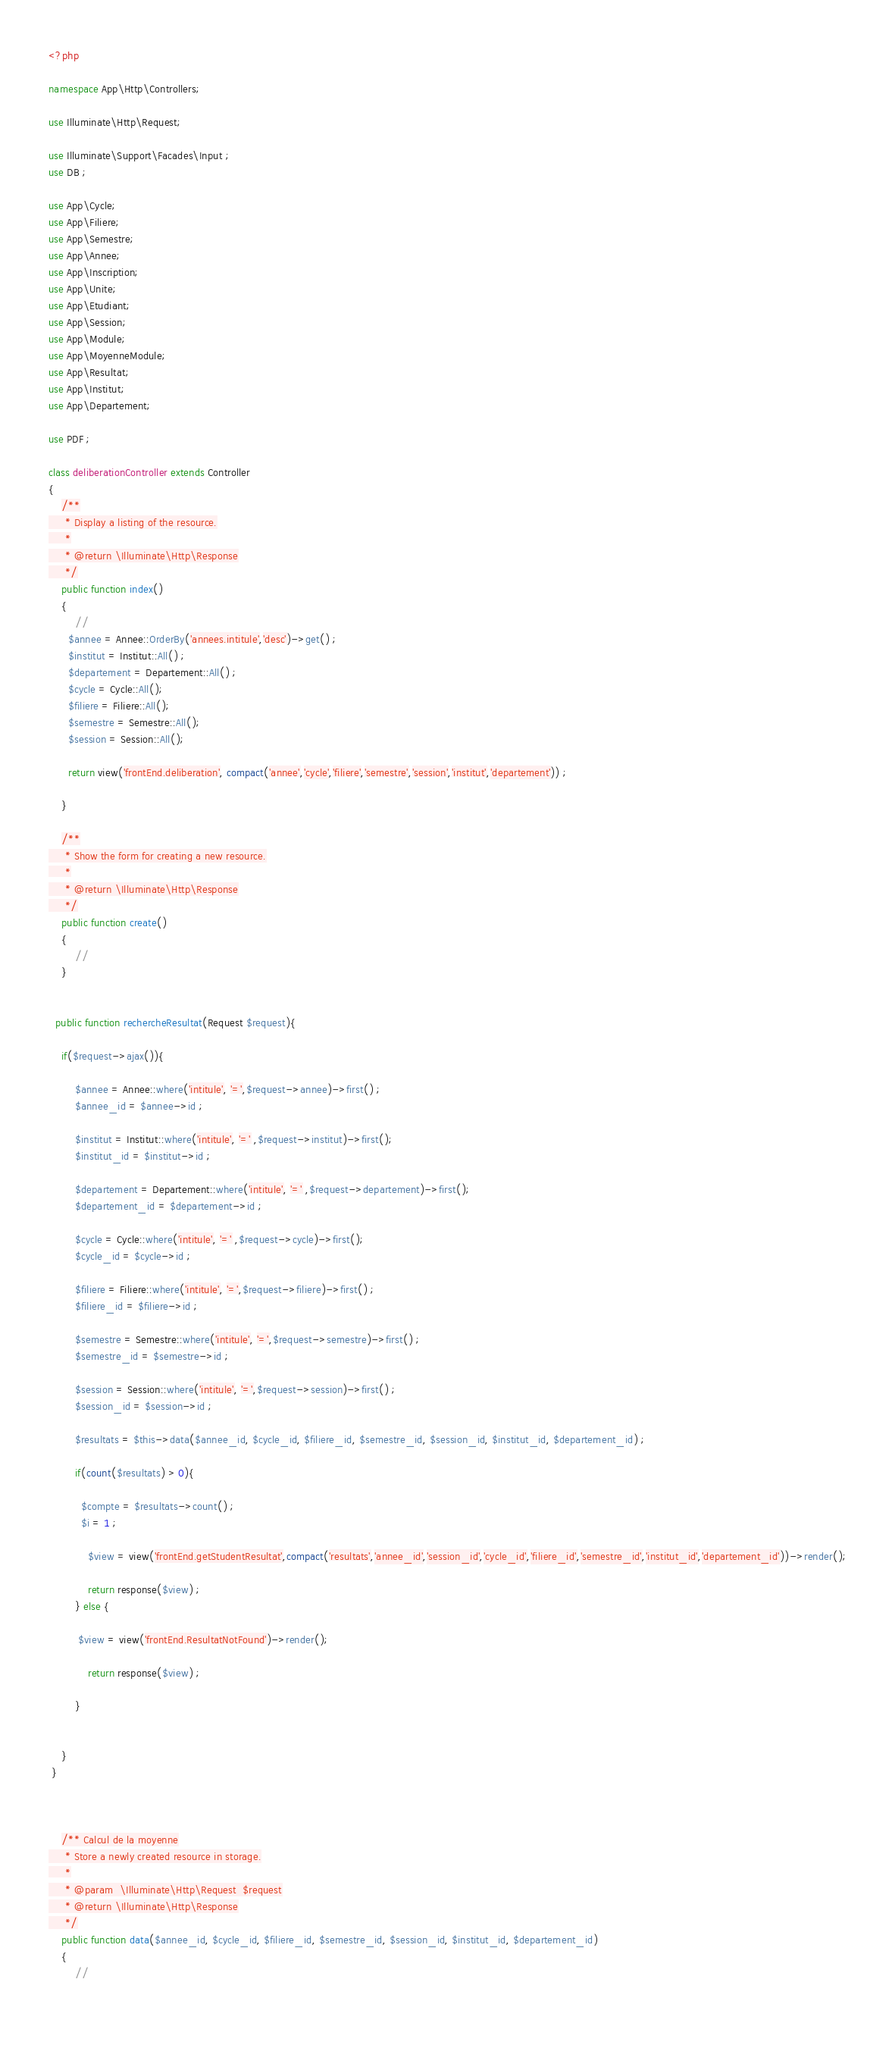<code> <loc_0><loc_0><loc_500><loc_500><_PHP_><?php

namespace App\Http\Controllers;

use Illuminate\Http\Request;

use Illuminate\Support\Facades\Input ;
use DB ;

use App\Cycle;
use App\Filiere;
use App\Semestre;
use App\Annee;
use App\Inscription;
use App\Unite;
use App\Etudiant;
use App\Session;
use App\Module;
use App\MoyenneModule;
use App\Resultat;
use App\Institut;
use App\Departement;

use PDF ;

class deliberationController extends Controller
{
    /**
     * Display a listing of the resource.
     *
     * @return \Illuminate\Http\Response
     */
    public function index()
    {
        //
      $annee = Annee::OrderBy('annees.intitule','desc')->get() ;
      $institut = Institut::All() ;
      $departement = Departement::All() ;
      $cycle = Cycle::All();
      $filiere = Filiere::All();
      $semestre = Semestre::All();
      $session = Session::All();

      return view('frontEnd.deliberation', compact('annee','cycle','filiere','semestre','session','institut','departement')) ;

    }

    /**
     * Show the form for creating a new resource.
     *
     * @return \Illuminate\Http\Response
     */
    public function create()
    {
        //
    }


  public function rechercheResultat(Request $request){

    if($request->ajax()){

        $annee = Annee::where('intitule', '=',$request->annee)->first() ;
        $annee_id = $annee->id ;

        $institut = Institut::where('intitule', '=' ,$request->institut)->first();
        $institut_id = $institut->id ;

        $departement = Departement::where('intitule', '=' ,$request->departement)->first();
        $departement_id = $departement->id ;

        $cycle = Cycle::where('intitule', '=' ,$request->cycle)->first();
        $cycle_id = $cycle->id ;

        $filiere = Filiere::where('intitule', '=',$request->filiere)->first() ;
        $filiere_id = $filiere->id ;

        $semestre = Semestre::where('intitule', '=',$request->semestre)->first() ;
        $semestre_id = $semestre->id ;

        $session = Session::where('intitule', '=',$request->session)->first() ;
        $session_id = $session->id ;

        $resultats = $this->data($annee_id, $cycle_id, $filiere_id, $semestre_id, $session_id, $institut_id, $departement_id) ;

        if(count($resultats) > 0){

          $compte = $resultats->count() ;
          $i = 1 ;

            $view = view('frontEnd.getStudentResultat',compact('resultats','annee_id','session_id','cycle_id','filiere_id','semestre_id','institut_id','departement_id'))->render();

            return response($view) ;
        } else {

         $view = view('frontEnd.ResultatNotFound')->render();

            return response($view) ;

        }


    }
 }



    /** Calcul de la moyenne
     * Store a newly created resource in storage.
     *
     * @param  \Illuminate\Http\Request  $request
     * @return \Illuminate\Http\Response
     */
    public function data($annee_id, $cycle_id, $filiere_id, $semestre_id, $session_id, $institut_id, $departement_id)
    {
        //
     </code> 